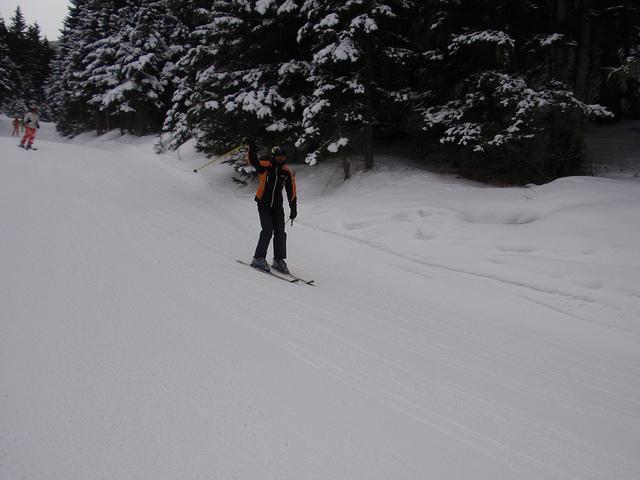How many orange flags are there?
Give a very brief answer. 0. 